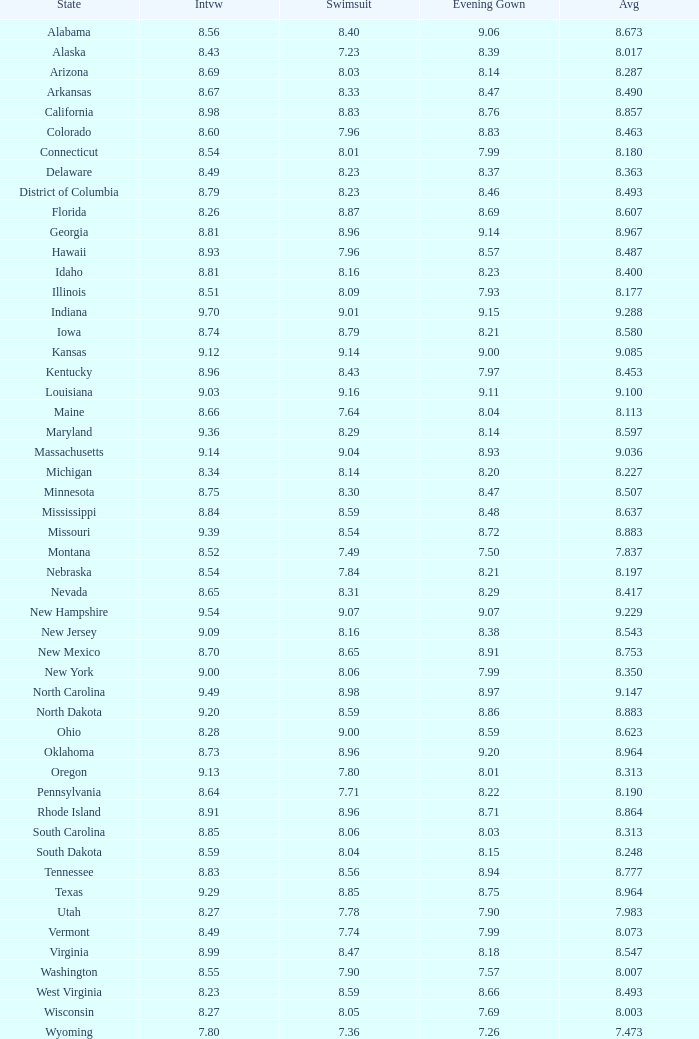Tell me the sum of interview for evening gown more than 8.37 and average of 8.363 None. 